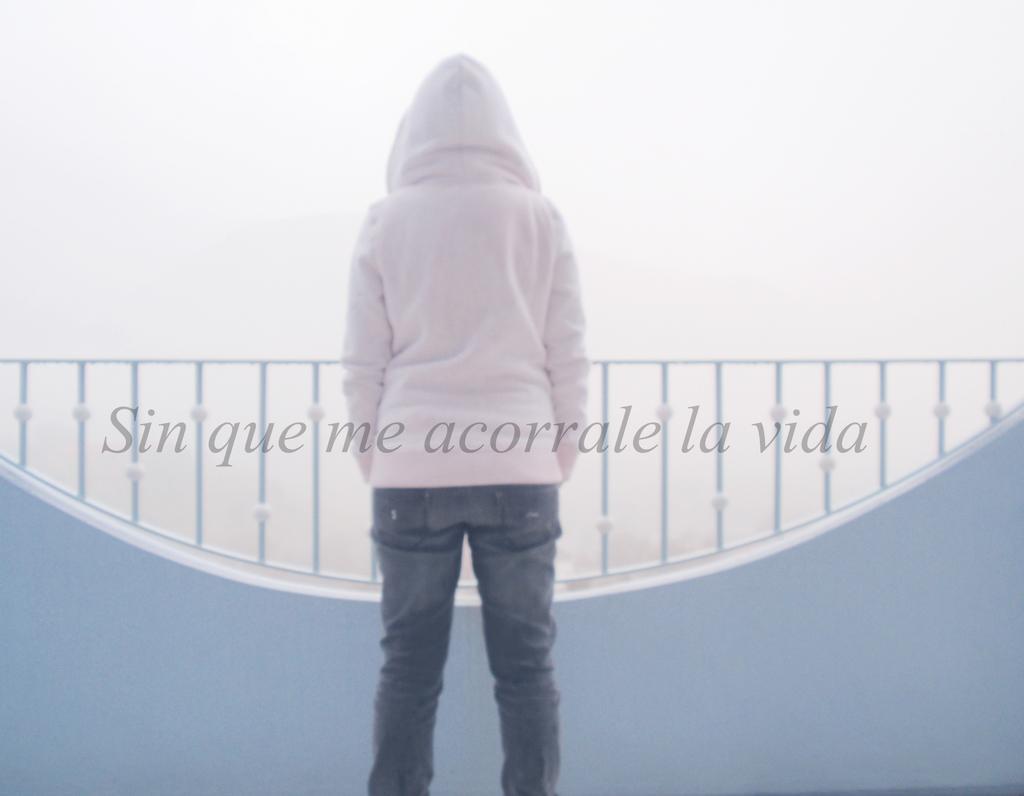Could you give a brief overview of what you see in this image? In this image we can see the back view of a person and the person is standing. Behind the person we can see the fence. On the image there is a text. 